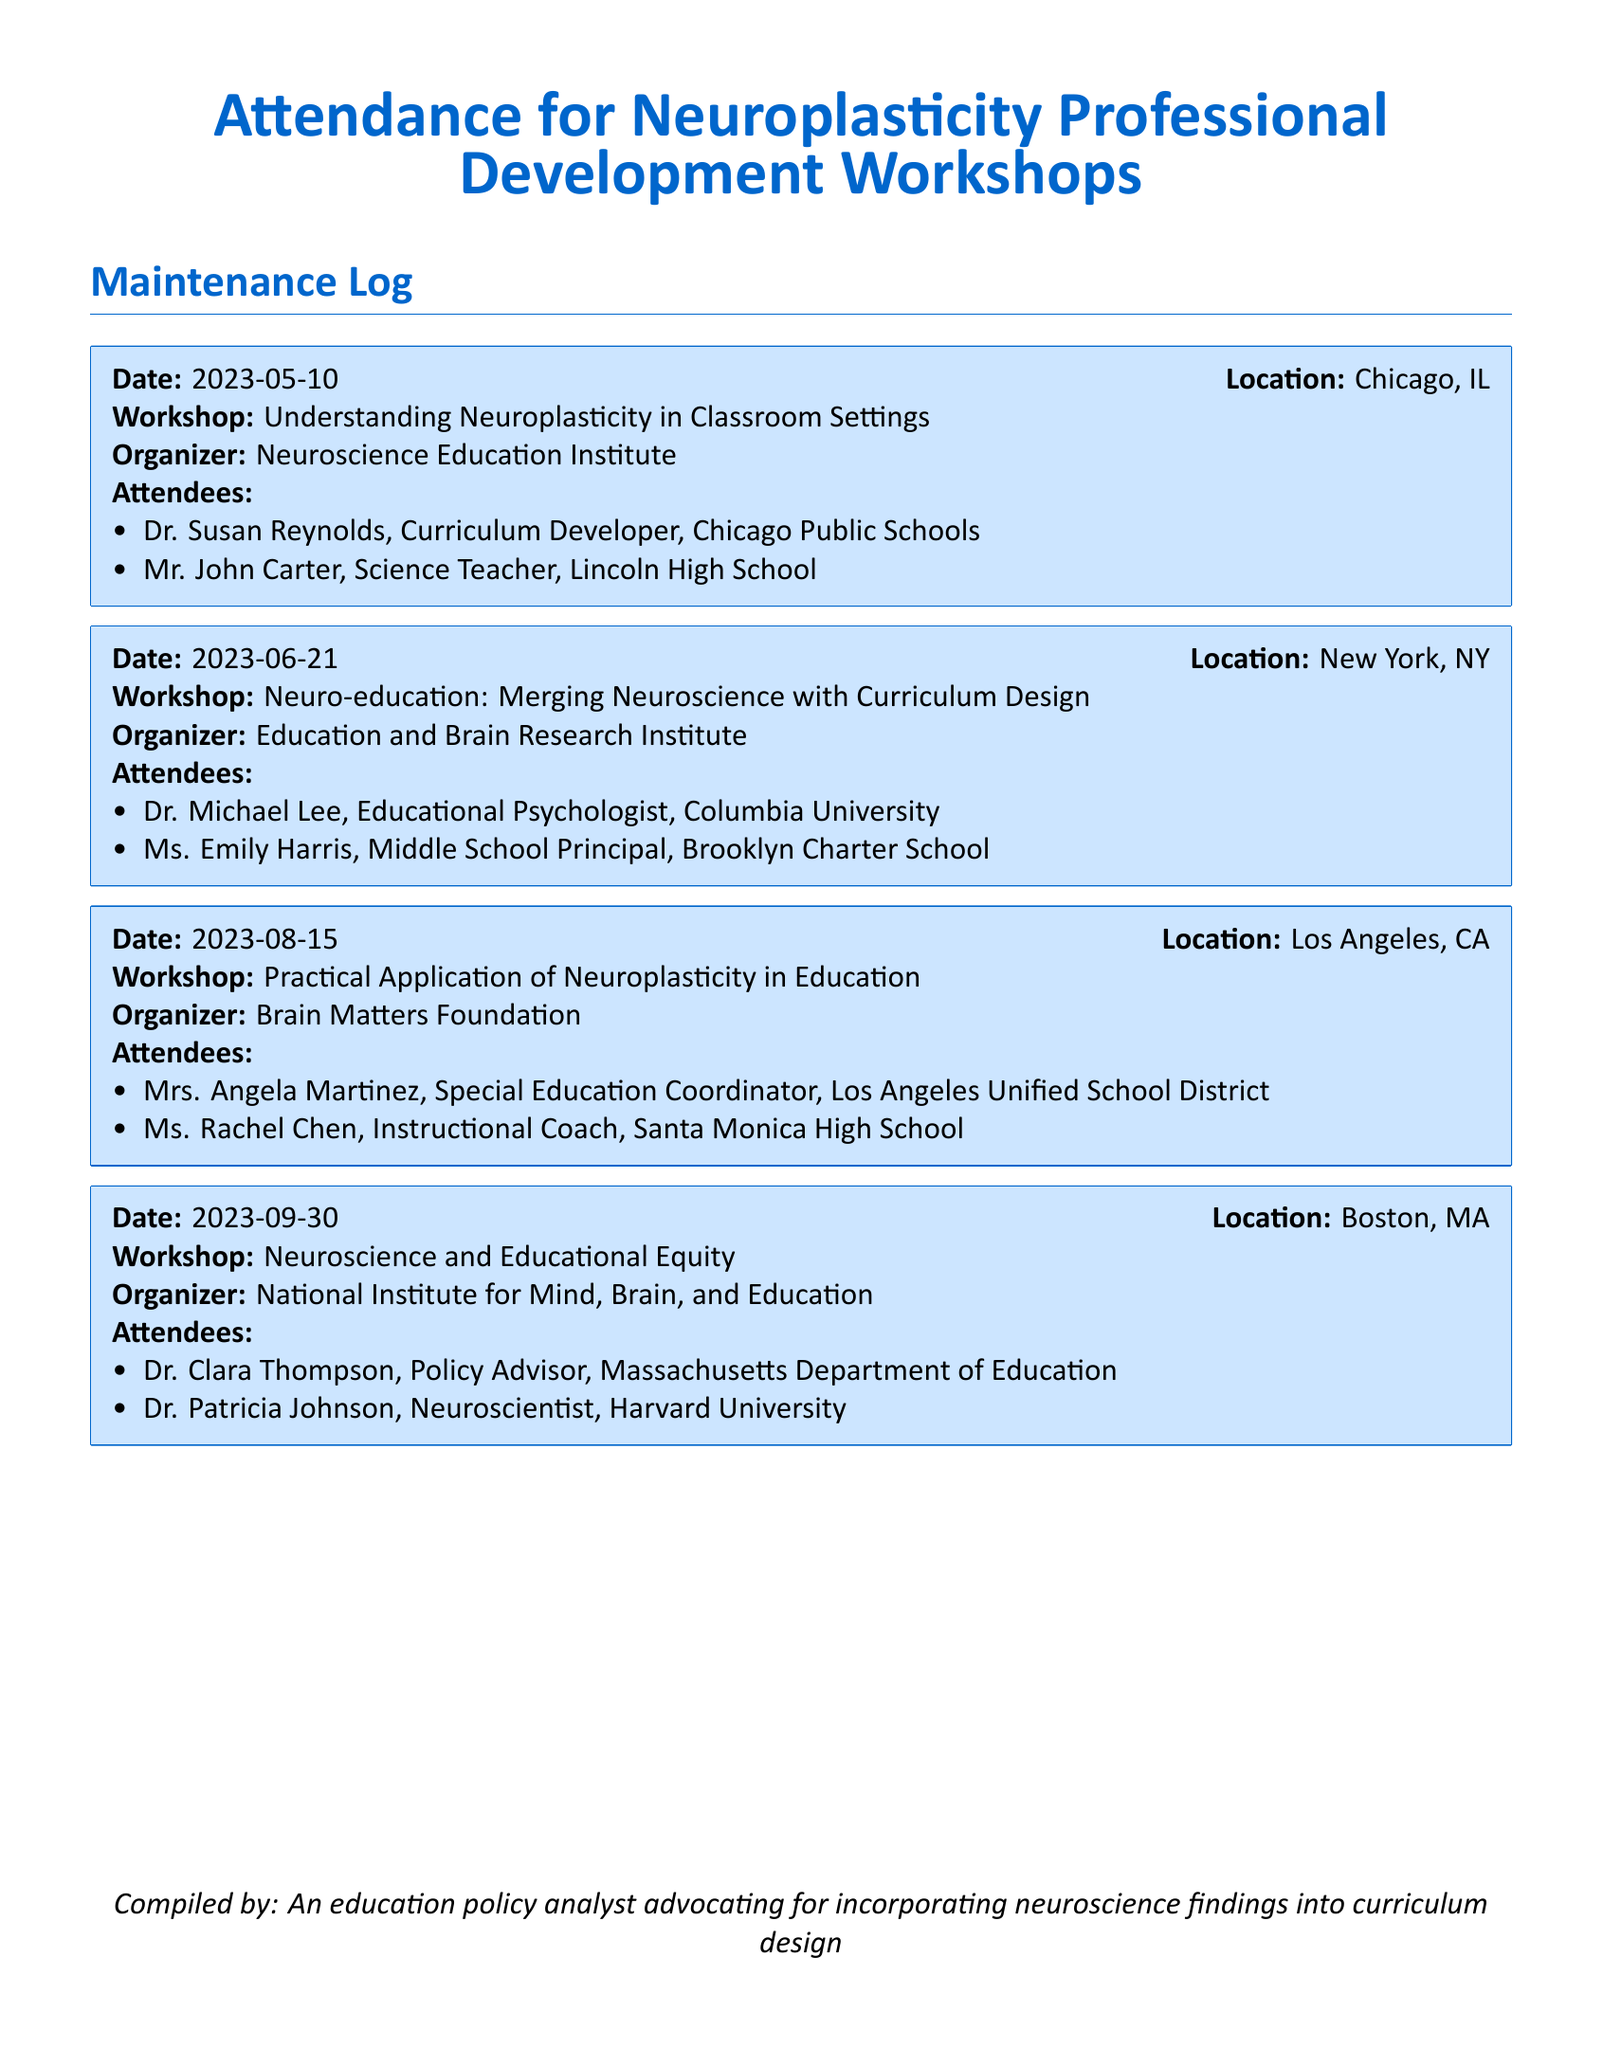What is the date of the workshop held in Chicago? The document lists the date for the workshop in Chicago, which is May 10, 2023.
Answer: May 10, 2023 Who was the organizer of the workshop titled "Neuroscience and Educational Equity"? Looking at the log, the workshop titled "Neuroscience and Educational Equity" was organized by the National Institute for Mind, Brain, and Education.
Answer: National Institute for Mind, Brain, and Education How many attendees were present at the workshop in Los Angeles? The document provides a list of attendees for the Los Angeles workshop, which includes two individuals.
Answer: 2 Which city hosted the workshop discussing "Neuro-education: Merging Neuroscience with Curriculum Design"? The workshop with this title took place in New York, NY as indicated in the attendance log.
Answer: New York, NY Which profession did Dr. Clara Thompson hold? According to the document, Dr. Clara Thompson is identified as a Policy Advisor for the Massachusetts Department of Education.
Answer: Policy Advisor What was the main focus of the workshop held on August 15? The document specifies that the main focus of the August 15 workshop was the practical application of neuroplasticity in education.
Answer: Practical Application of Neuroplasticity in Education Who attended the workshop in Chicago? In the maintenance log, the attendees listed for the Chicago workshop are Dr. Susan Reynolds and Mr. John Carter.
Answer: Dr. Susan Reynolds, Mr. John Carter What type of document is this? The document is stated to be an Attendance log for Neuroplasticity Professional Development Workshops.
Answer: Attendance log 